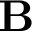<formula> <loc_0><loc_0><loc_500><loc_500>B</formula> 